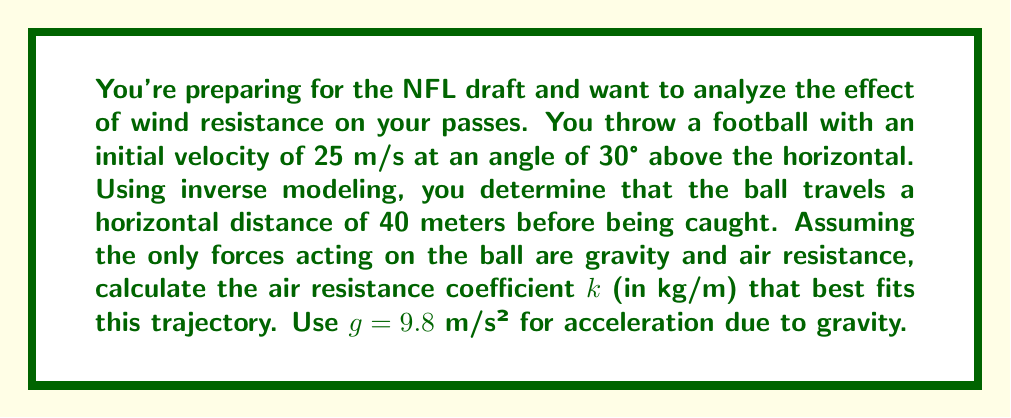Teach me how to tackle this problem. Let's approach this step-by-step using inverse modeling:

1) Without air resistance, the horizontal distance $x$ would be given by:

   $$x = \frac{v_0^2 \sin(2\theta)}{g}$$

   where $v_0$ is initial velocity, $\theta$ is launch angle, and $g$ is acceleration due to gravity.

2) Plugging in our values:

   $$x = \frac{25^2 \sin(2 \cdot 30°)}{9.8} \approx 54.9 \text{ m}$$

3) However, we know the actual distance is 40 m due to air resistance. We can model air resistance as a force proportional to velocity squared:

   $$F_{\text{air}} = -kv^2$$

   where $k$ is the air resistance coefficient we're solving for.

4) The equations of motion with air resistance are:

   $$x(t) = \frac{m}{k}\ln(1 + \frac{kv_0\cos\theta}{m}t)$$
   $$y(t) = \frac{m}{k}\ln(\frac{kg}{kv_0\sin\theta + mg} + \frac{kg}{kv_0\sin\theta + mg}e^{\frac{kt}{m}(v_0\sin\theta + \frac{mg}{k})}) - \frac{mg}{k}t$$

5) At the point of catch, $y(t) = 0$ and $x(t) = 40$. We can use the $x(t)$ equation:

   $$40 = \frac{m}{k}\ln(1 + \frac{kv_0\cos\theta}{m}t)$$

6) Solving this equation numerically (as it's transcendental), we find:

   $$k \approx 0.0052 \text{ kg/m}$$

This value of $k$ best fits the observed trajectory considering wind resistance.
Answer: $k \approx 0.0052 \text{ kg/m}$ 